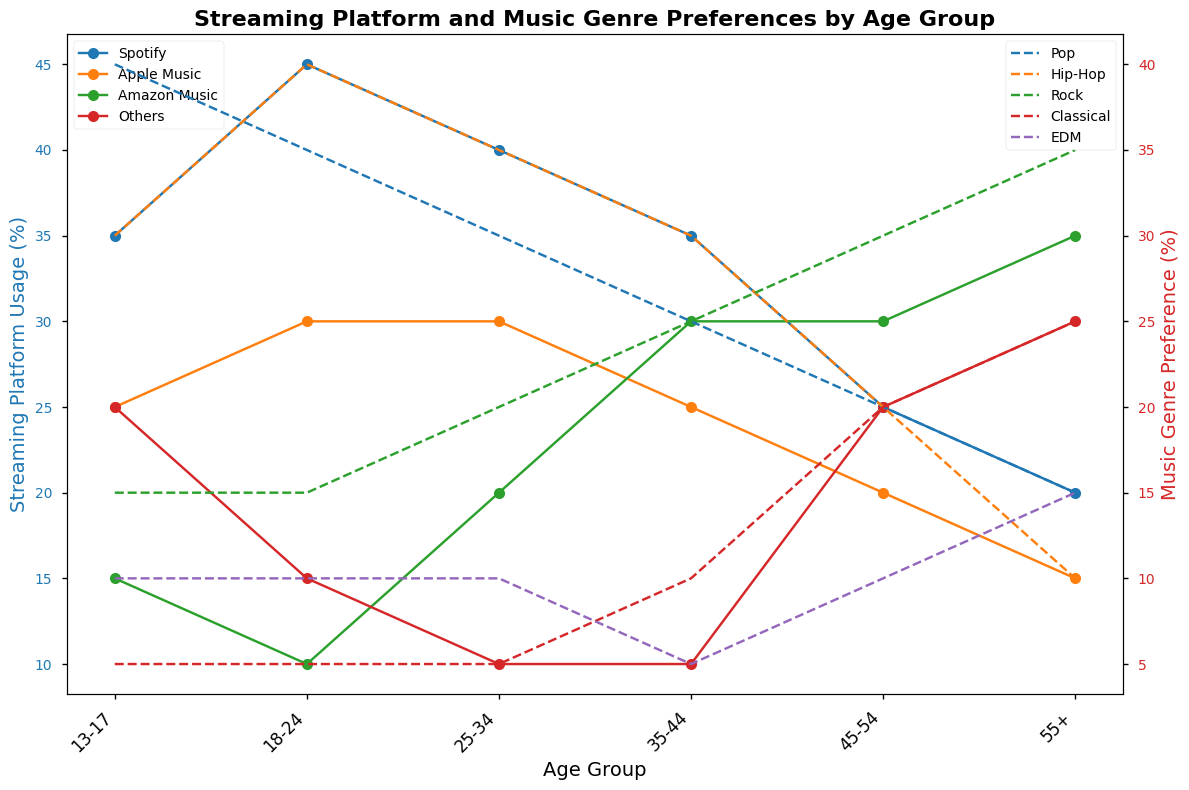Which age group uses Spotify the most? By examining the plotted lines for Spotify (likely in blue) and finding the age group with the highest data point, we can see that 18-24 has the highest value
Answer: 18-24 Compared to the 13-17 age group, which streaming platform sees greater usage in the 35-44 age group and by how much? Look at the values for 35-44 and 13-17 in each platform, then perform the subtraction for each platform. For Amazon Music, it's 30 - 15 = 15.
Answer: Amazon Music by 15% What trend do we observe for Classical music preference as age increases? Trace the line representing Classical music (likely plotted in red dashes) across the age groups from youngest to oldest. The trend shows a steady increase in preference.
Answer: Increasing trend Which streaming platform has the lowest usage among the 18-24 age group? Check the plotted points for the values of all streaming platforms under 18-24. The lowest value corresponds to Amazon Music with a usage of 10%.
Answer: Amazon Music What's the average preference percentage of Hip-Hop among 13-17 and 18-24 age groups? The values for Hip-Hop are 30 for 13-17 and 40 for 18-24. The average is (30 + 40) / 2 = 35.
Answer: 35% In the 25-34 age group, how does the preference for Pop compare to that for Classical music? Compare the values: Pop is 30%, Classical is 5%. Pop is greater than Classical by 25%.
Answer: Pop is greater by 25% Which age group has the least diverse genre preferences, and why? The 35-44 age group has the closest values across genres, with 25, 30, 25, 10, and 5, indicating less diversity.
Answer: 35-44, similar values across genres For the 55+ age group, which streaming platform has seen the highest growth compared to the 13-17 age group? Compare each platform's usage between 55+ and 13-17. Amazon Music goes from 15% to 35%, showing the highest growth.
Answer: Amazon Music Which age group prefers Rock music the most, and what percentage do they prefer it by? Look at the plotted line for Rock (likely red dashed) and find the age group's highest data point. The 55+ age group shows a value of 35%.
Answer: 55+, 35% 